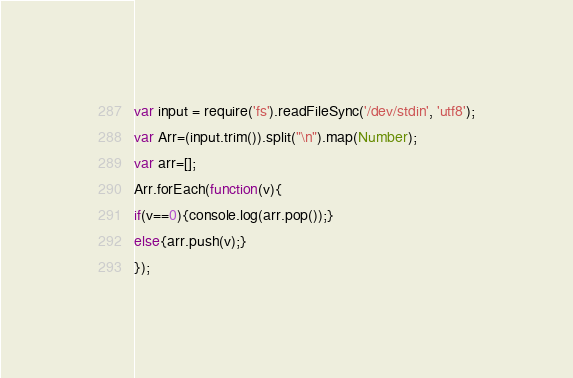Convert code to text. <code><loc_0><loc_0><loc_500><loc_500><_JavaScript_>var input = require('fs').readFileSync('/dev/stdin', 'utf8');
var Arr=(input.trim()).split("\n").map(Number);
var arr=[];
Arr.forEach(function(v){
if(v==0){console.log(arr.pop());}
else{arr.push(v);}
});</code> 